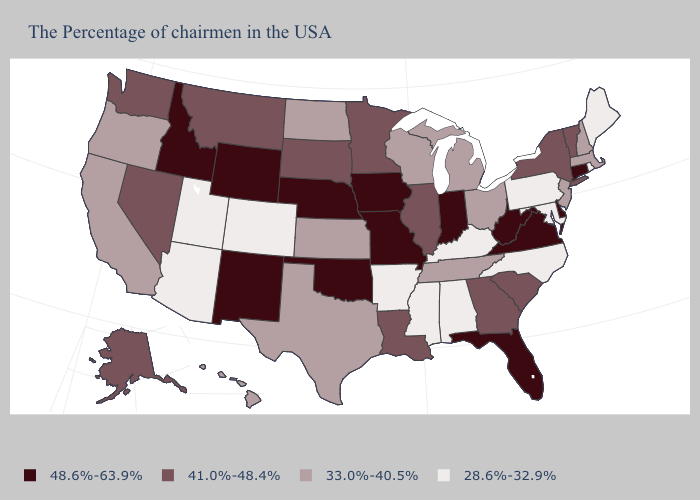Name the states that have a value in the range 33.0%-40.5%?
Keep it brief. Massachusetts, New Hampshire, New Jersey, Ohio, Michigan, Tennessee, Wisconsin, Kansas, Texas, North Dakota, California, Oregon, Hawaii. Does West Virginia have the highest value in the South?
Give a very brief answer. Yes. What is the value of Mississippi?
Short answer required. 28.6%-32.9%. What is the value of Louisiana?
Quick response, please. 41.0%-48.4%. Does Texas have a lower value than Pennsylvania?
Quick response, please. No. What is the lowest value in the USA?
Short answer required. 28.6%-32.9%. What is the value of Arizona?
Answer briefly. 28.6%-32.9%. Does Vermont have a higher value than Colorado?
Keep it brief. Yes. Among the states that border Wyoming , does Utah have the lowest value?
Answer briefly. Yes. What is the lowest value in the USA?
Short answer required. 28.6%-32.9%. Among the states that border Utah , which have the highest value?
Short answer required. Wyoming, New Mexico, Idaho. What is the value of Colorado?
Quick response, please. 28.6%-32.9%. What is the value of Oregon?
Give a very brief answer. 33.0%-40.5%. Does South Dakota have the highest value in the USA?
Short answer required. No. Which states have the lowest value in the USA?
Be succinct. Maine, Rhode Island, Maryland, Pennsylvania, North Carolina, Kentucky, Alabama, Mississippi, Arkansas, Colorado, Utah, Arizona. 